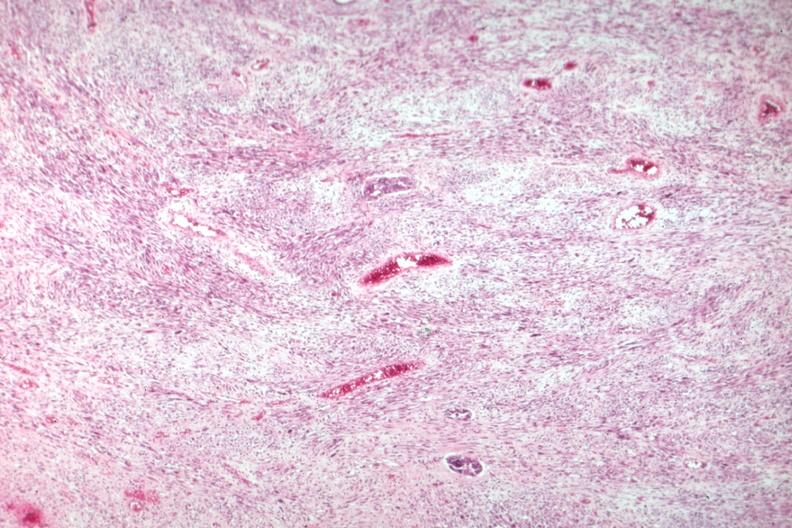what is present?
Answer the question using a single word or phrase. Mixed mesodermal tumor 